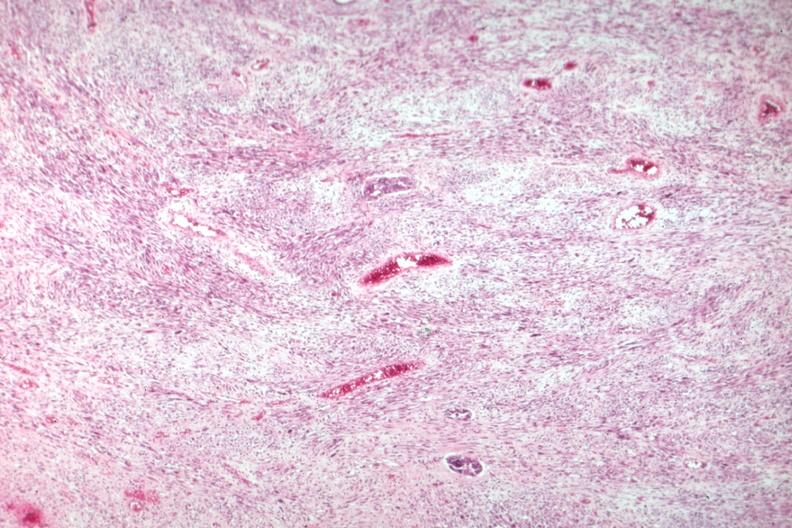what is present?
Answer the question using a single word or phrase. Mixed mesodermal tumor 